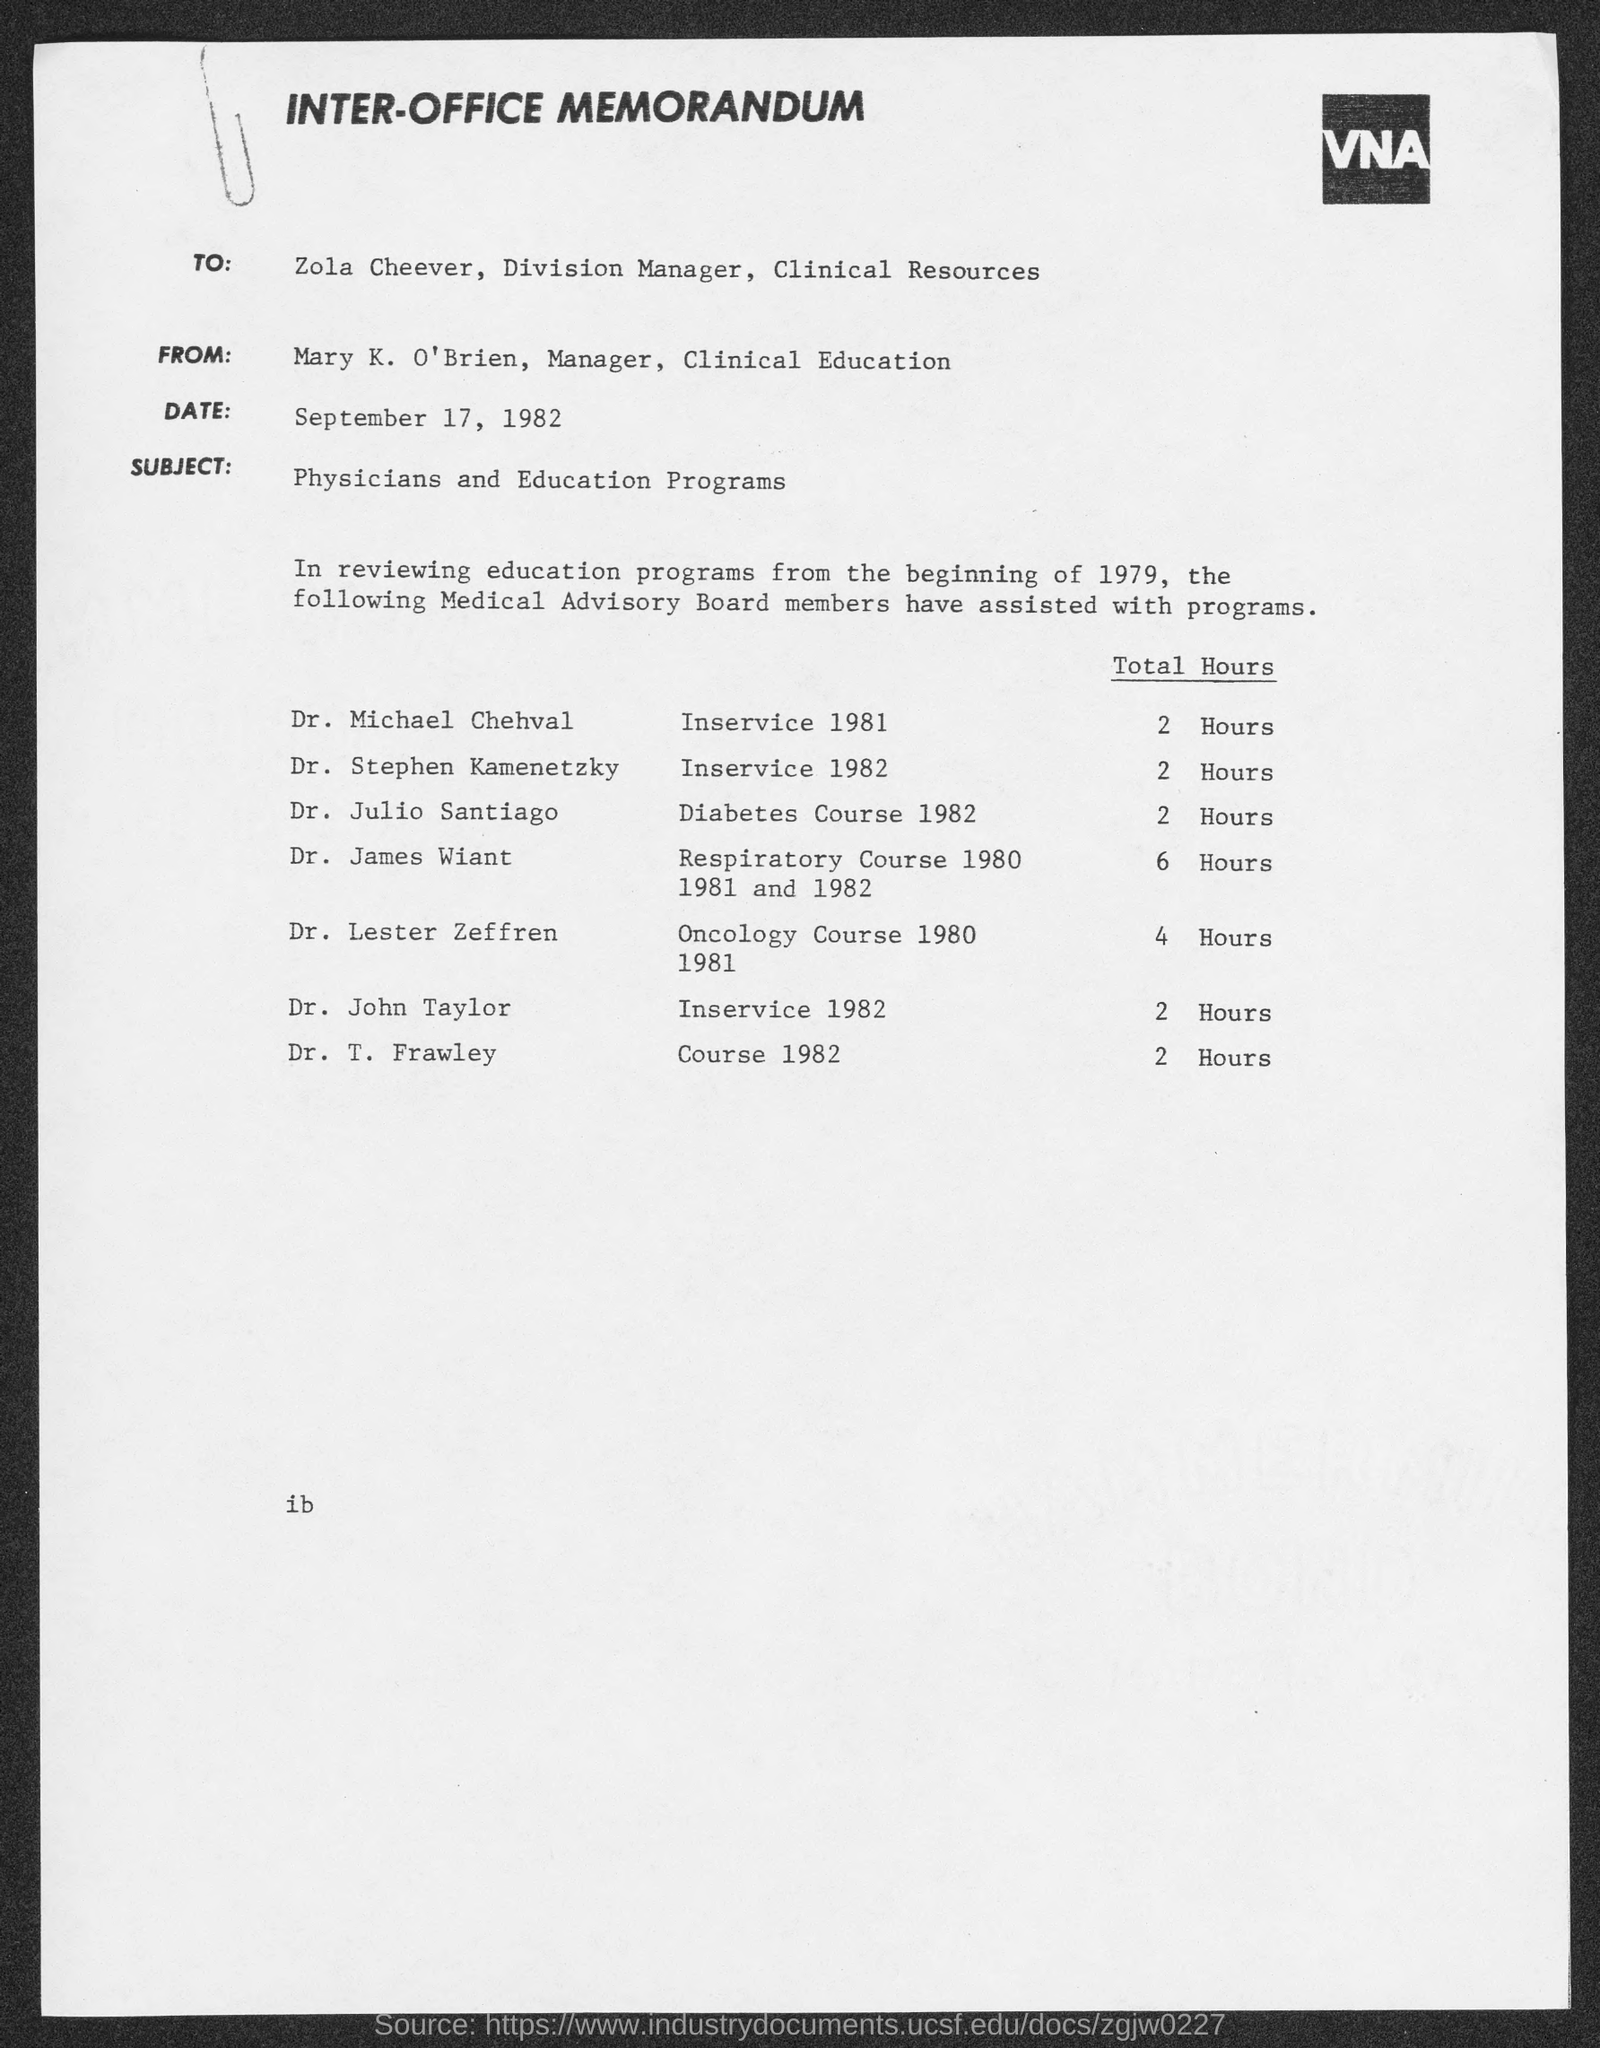List a handful of essential elements in this visual. The memorandum's sender is Mary K. O'Brien, who is the Manager of Clinical Education. The addressee of this memorandum is Zola Cheever. This is an inter-office memorandum, a type of communication. The subject mentioned in the memorandum is physicians and education programs. 